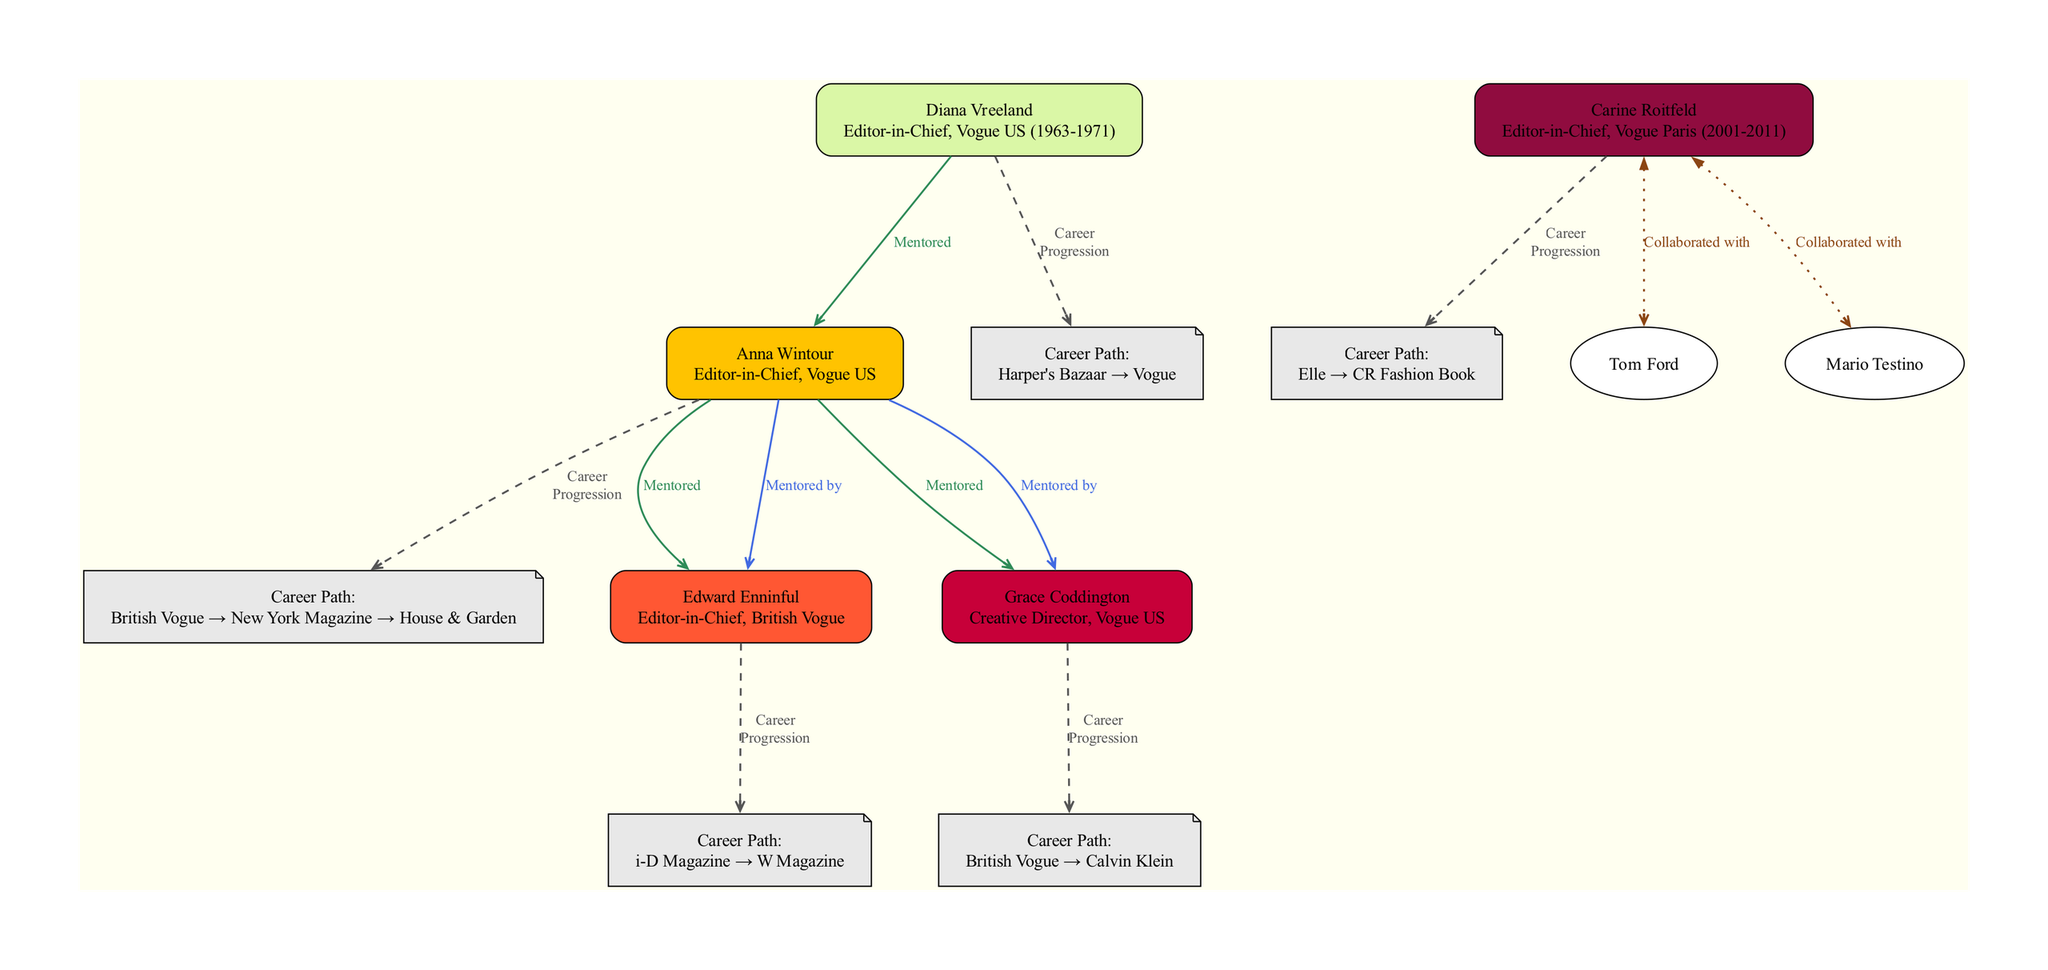What role does Anna Wintour hold? The diagram indicates that Anna Wintour's role is "Editor-in-Chief, Vogue US." This information is found directly beneath her name in the node.
Answer: Editor-in-Chief, Vogue US Which magazine did Diana Vreeland work at before Vogue? The diagram presents Diana Vreeland's career path, which shows that she worked at "Harper's Bazaar" before joining Vogue. This is explicitly mentioned in her career path node.
Answer: Harper's Bazaar How many mentees did Anna Wintour have? By looking at the diagram, we can see that Anna Wintour has two mentees listed: Edward Enninful and Grace Coddington. Counting these names gives us the total.
Answer: 2 Who mentored Edward Enninful? The diagram specifies that Edward Enninful was mentored by Anna Wintour, which is shown in the edge connecting them with the label "Mentored by."
Answer: Anna Wintour What was the role of Carine Roitfeld? The diagram indicates that Carine Roitfeld's role is "Editor-in-Chief, Vogue Paris (2001-2011)," as shown in her node.
Answer: Editor-in-Chief, Vogue Paris (2001-2011) Name one collaborator of Carine Roitfeld. The diagram highlights that Carine Roitfeld collaborated with both Tom Ford and Mario Testino. Since the question asks for one, we can select either one.
Answer: Tom Ford What career path includes "i-D Magazine"? The diagram illustrates that "i-D Magazine" is part of Edward Enninful's career path as listed in his node. To find this, we look specifically at his career path section.
Answer: i-D Magazine Which editor-in-chief has the most reported mentees? By analyzing the diagram, we see that Anna Wintour has two mentees, while the others report fewer or none. Hence, Anna Wintour has the most.
Answer: Anna Wintour How many total career paths are listed in the diagram? By reviewing the diagrams of all editors-in-chief represented, their respective career paths amount to a total of five unique paths as summarized through all nodes.
Answer: 5 